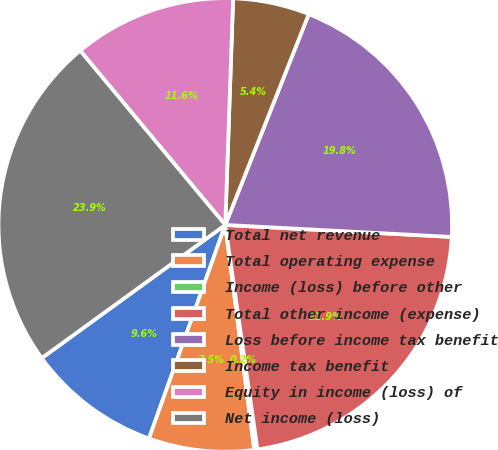Convert chart to OTSL. <chart><loc_0><loc_0><loc_500><loc_500><pie_chart><fcel>Total net revenue<fcel>Total operating expense<fcel>Income (loss) before other<fcel>Total other income (expense)<fcel>Loss before income tax benefit<fcel>Income tax benefit<fcel>Equity in income (loss) of<fcel>Net income (loss)<nl><fcel>9.55%<fcel>7.5%<fcel>0.23%<fcel>21.89%<fcel>19.84%<fcel>5.45%<fcel>11.6%<fcel>23.94%<nl></chart> 